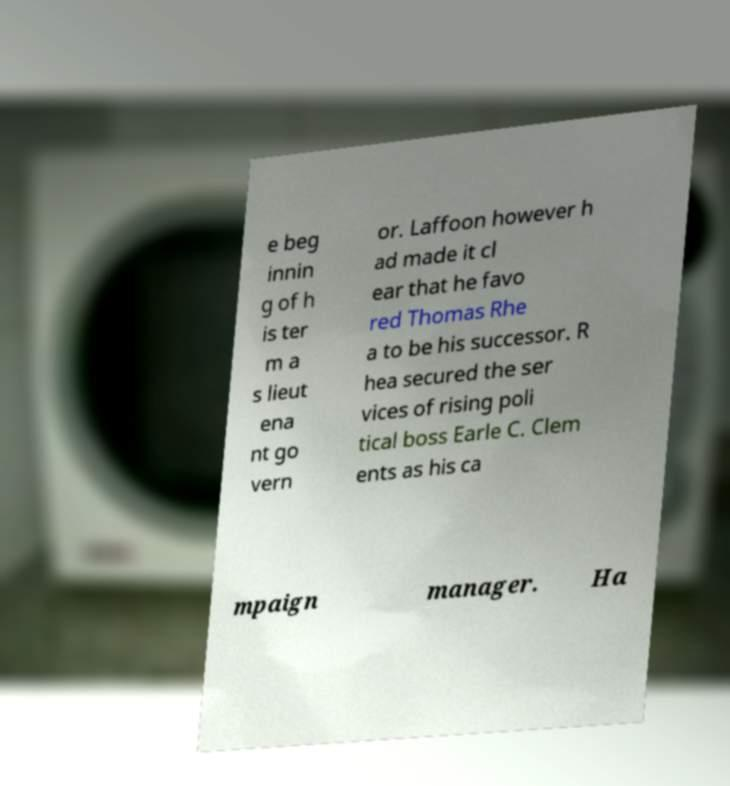Could you assist in decoding the text presented in this image and type it out clearly? e beg innin g of h is ter m a s lieut ena nt go vern or. Laffoon however h ad made it cl ear that he favo red Thomas Rhe a to be his successor. R hea secured the ser vices of rising poli tical boss Earle C. Clem ents as his ca mpaign manager. Ha 